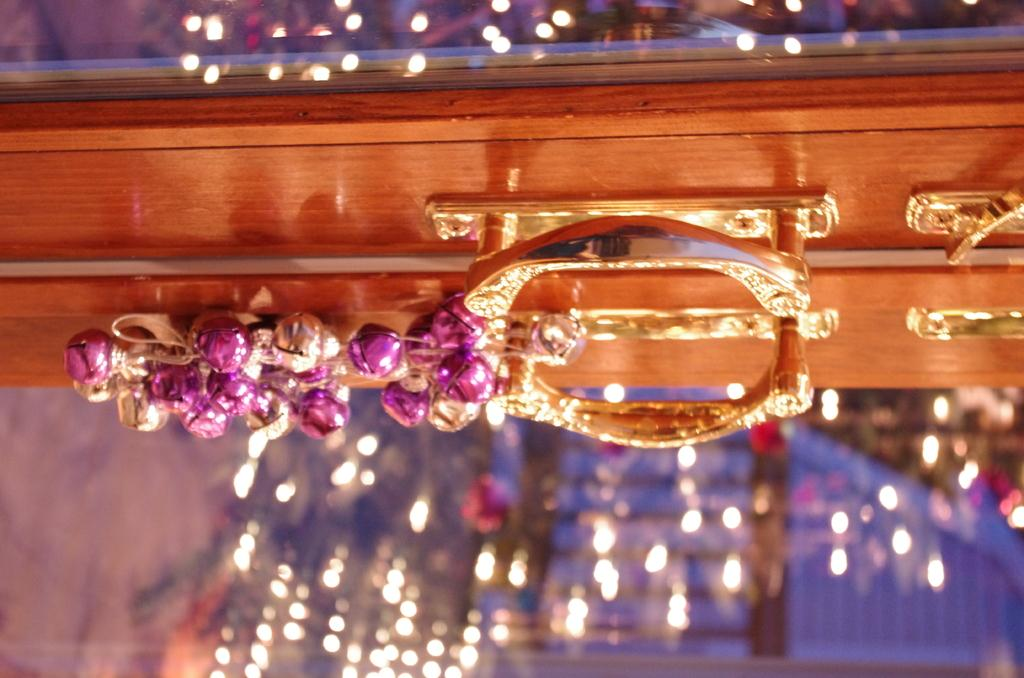What is the color of the box in the image? The box in the image is brown. What is the handle of the box made of? The handle of the box is gold in color. What can be seen in the background of the image? There are lights visible in the background of the image. How does the box show respect to the spy in the image? There is no spy present in the image, and the box does not show respect to anyone. 